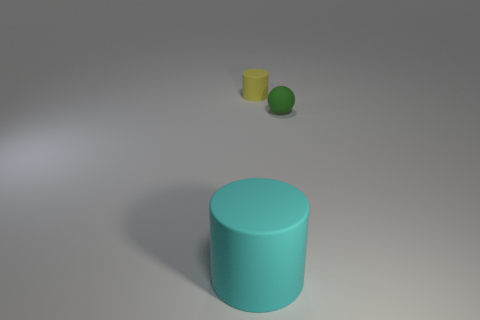Could you guess the purpose of this arrangement? The purpose isn't immediately clear, as it appears to be an abstract arrangement. It could serve as a visual composition exercise, focusing on colors, shapes, and the interplay of light and shadow, possibly for artistic or educational purposes. How would you describe the overall mood or atmosphere created by this composition? The image conveys a sense of calm and simplicity. The minimalistic arrangement, coupled with the muted color palette and soft lighting, creates a serene atmosphere that's soothing to the observer. 